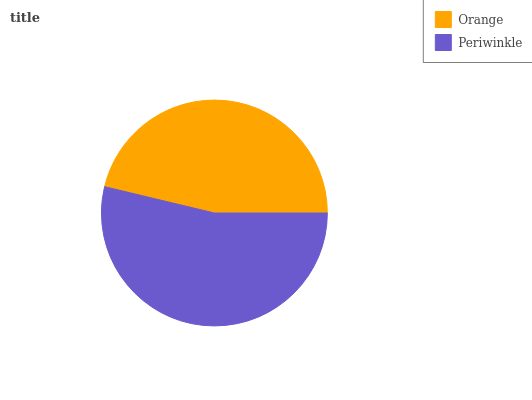Is Orange the minimum?
Answer yes or no. Yes. Is Periwinkle the maximum?
Answer yes or no. Yes. Is Periwinkle the minimum?
Answer yes or no. No. Is Periwinkle greater than Orange?
Answer yes or no. Yes. Is Orange less than Periwinkle?
Answer yes or no. Yes. Is Orange greater than Periwinkle?
Answer yes or no. No. Is Periwinkle less than Orange?
Answer yes or no. No. Is Periwinkle the high median?
Answer yes or no. Yes. Is Orange the low median?
Answer yes or no. Yes. Is Orange the high median?
Answer yes or no. No. Is Periwinkle the low median?
Answer yes or no. No. 